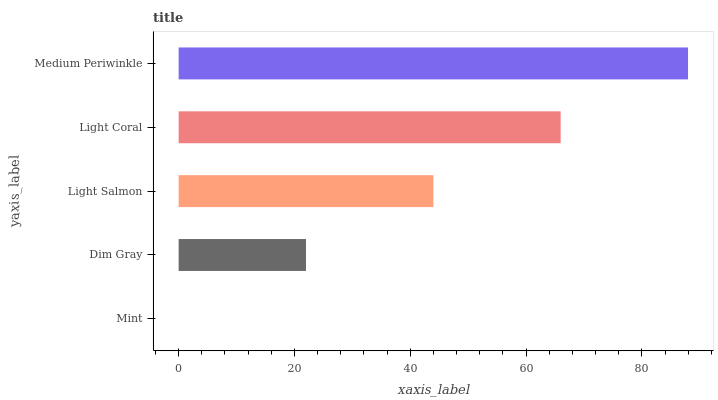Is Mint the minimum?
Answer yes or no. Yes. Is Medium Periwinkle the maximum?
Answer yes or no. Yes. Is Dim Gray the minimum?
Answer yes or no. No. Is Dim Gray the maximum?
Answer yes or no. No. Is Dim Gray greater than Mint?
Answer yes or no. Yes. Is Mint less than Dim Gray?
Answer yes or no. Yes. Is Mint greater than Dim Gray?
Answer yes or no. No. Is Dim Gray less than Mint?
Answer yes or no. No. Is Light Salmon the high median?
Answer yes or no. Yes. Is Light Salmon the low median?
Answer yes or no. Yes. Is Dim Gray the high median?
Answer yes or no. No. Is Mint the low median?
Answer yes or no. No. 